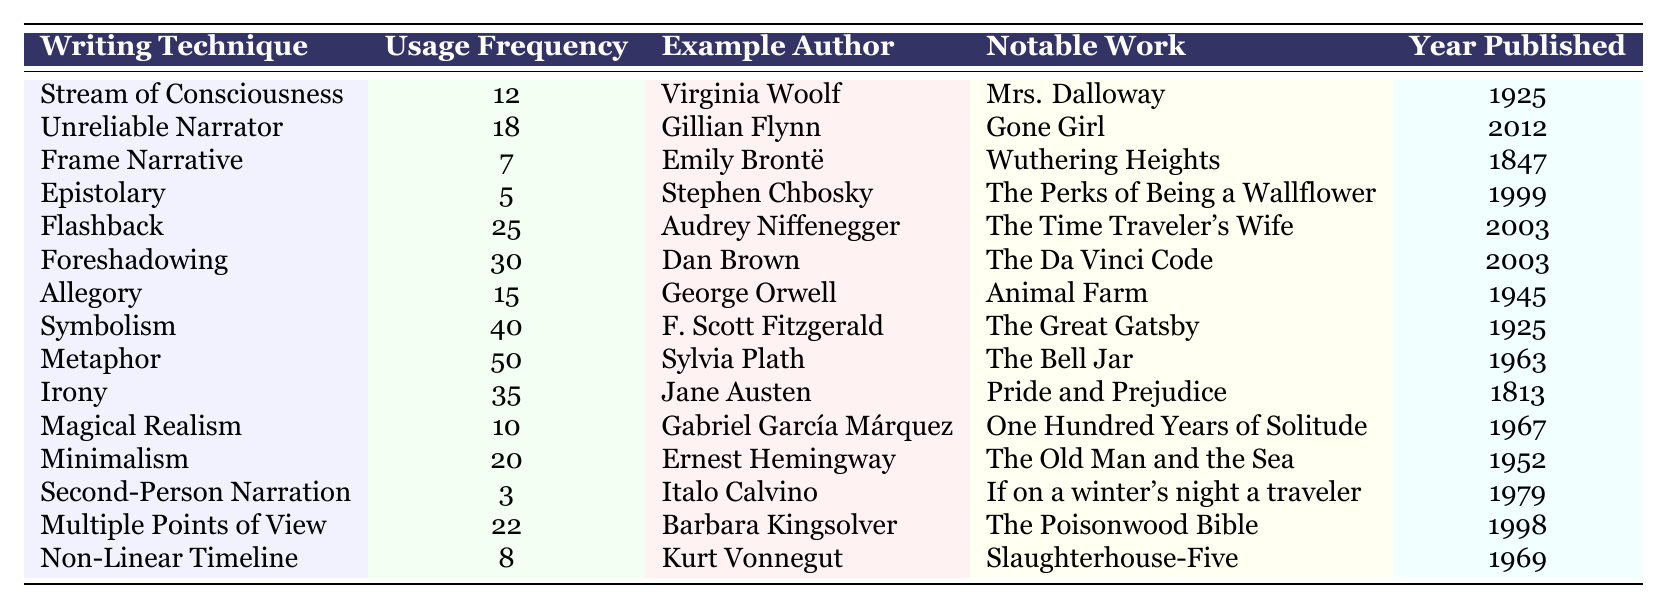What writing technique has the highest usage frequency? By looking at the "Usage Frequency" column, the writing technique with the highest value is "Metaphor," which has a frequency of 50.
Answer: Metaphor Which author is associated with the writing technique "Magical Realism"? The table shows that the author associated with "Magical Realism" is Gabriel García Márquez.
Answer: Gabriel García Márquez What is the average usage frequency of all listed writing techniques? To find the average, sum the usage frequencies (12 + 18 + 7 + 5 + 25 + 30 + 15 + 40 + 50 + 35 + 10 + 20 + 3 + 22 + 8 =  273) and divide by the number of techniques (15): 273/15 = 18.2.
Answer: 18.2 Is "Second-Person Narration" one of the techniques with high usage frequency? The usage frequency for "Second-Person Narration" is 3, which is relatively low compared to others in the table. Thus, it is not considered high usage.
Answer: No What is the difference in usage frequency between "Foreshadowing" and "Flashback"? The frequency of "Foreshadowing" is 30 and for "Flashback" it is 25. The difference is 30 - 25 = 5.
Answer: 5 Which writing technique has the same year of publication as "The Great Gatsby"? "The Great Gatsby" was published in 1925, and looking at the table, both "Stream of Consciousness" and "Symbolism" share the same publication year.
Answer: Stream of Consciousness, Symbolism Which technique has the lowest usage frequency and who is the associated author? "Second-Person Narration" has the lowest frequency at 3, and it is associated with Italo Calvino.
Answer: Second-Person Narration, Italo Calvino What percentage of the writing techniques have a usage frequency greater than 20? There are 15 techniques total, with 8 techniques having a frequency greater than 20. The percentage is (8/15) * 100 = 53.33%.
Answer: 53.33% Name the author associated with the "Unreliable Narrator" and their notable work. The author for "Unreliable Narrator" is Gillian Flynn, and the notable work is "Gone Girl."
Answer: Gillian Flynn, Gone Girl If you combine the usage frequency of "Frame Narrative" and "Non-Linear Timeline," what would the total be? The usage frequency for "Frame Narrative" is 7 and for "Non-Linear Timeline" is 8. Adding these gives 7 + 8 = 15.
Answer: 15 